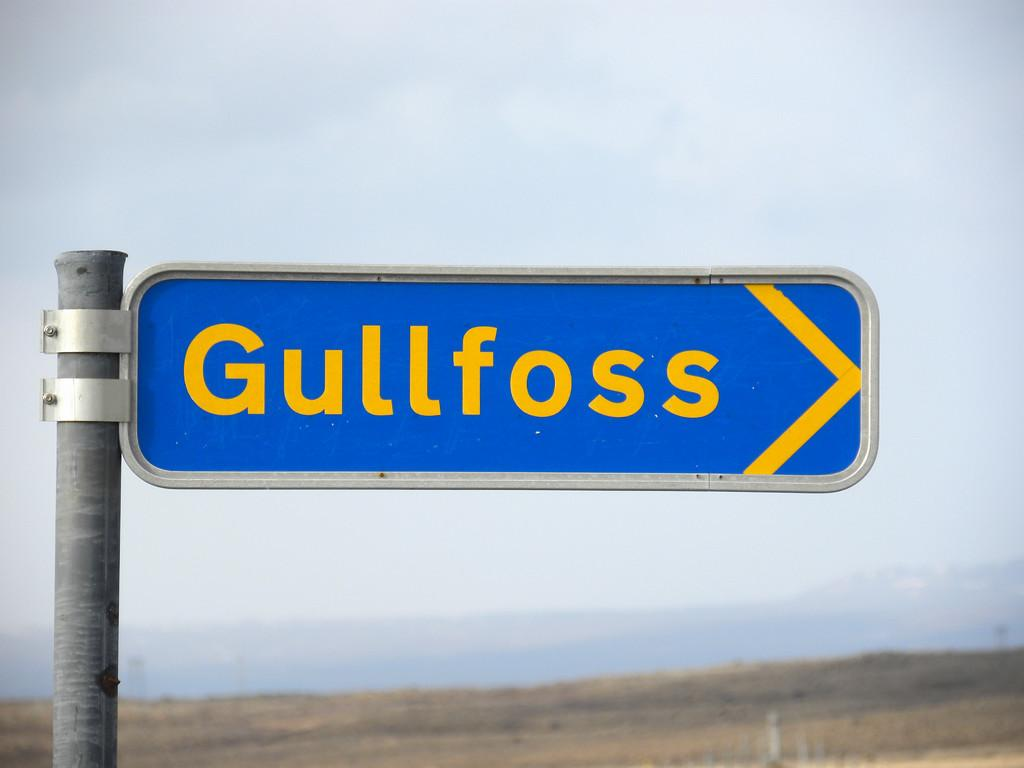<image>
Summarize the visual content of the image. A blue and yellow sign shows that Gullfoss is to the right. 